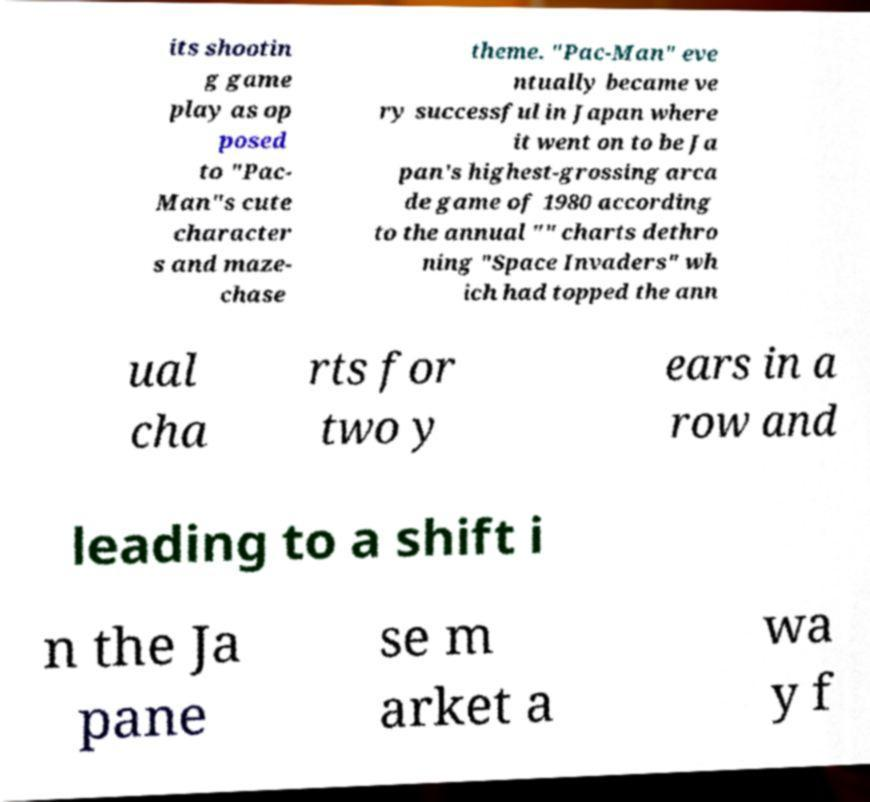Can you read and provide the text displayed in the image?This photo seems to have some interesting text. Can you extract and type it out for me? its shootin g game play as op posed to "Pac- Man"s cute character s and maze- chase theme. "Pac-Man" eve ntually became ve ry successful in Japan where it went on to be Ja pan's highest-grossing arca de game of 1980 according to the annual "" charts dethro ning "Space Invaders" wh ich had topped the ann ual cha rts for two y ears in a row and leading to a shift i n the Ja pane se m arket a wa y f 